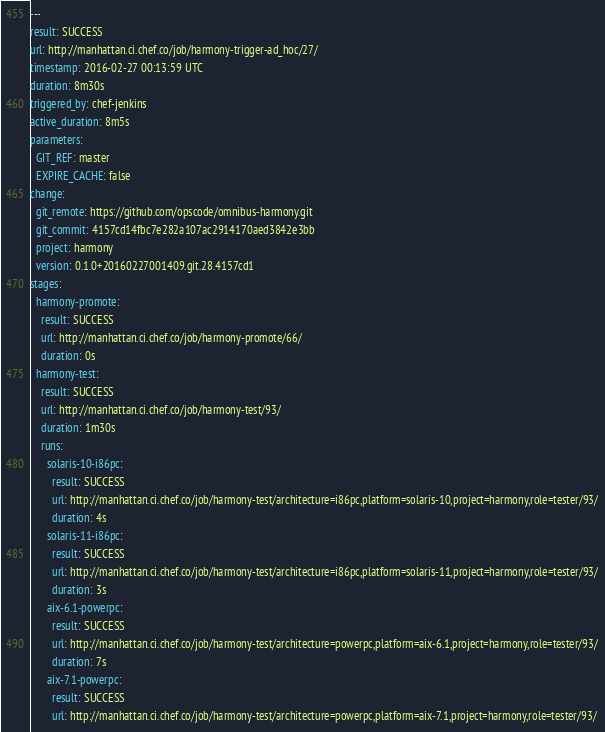Convert code to text. <code><loc_0><loc_0><loc_500><loc_500><_YAML_>---
result: SUCCESS
url: http://manhattan.ci.chef.co/job/harmony-trigger-ad_hoc/27/
timestamp: 2016-02-27 00:13:59 UTC
duration: 8m30s
triggered_by: chef-jenkins
active_duration: 8m5s
parameters:
  GIT_REF: master
  EXPIRE_CACHE: false
change:
  git_remote: https://github.com/opscode/omnibus-harmony.git
  git_commit: 4157cd14fbc7e282a107ac2914170aed3842e3bb
  project: harmony
  version: 0.1.0+20160227001409.git.28.4157cd1
stages:
  harmony-promote:
    result: SUCCESS
    url: http://manhattan.ci.chef.co/job/harmony-promote/66/
    duration: 0s
  harmony-test:
    result: SUCCESS
    url: http://manhattan.ci.chef.co/job/harmony-test/93/
    duration: 1m30s
    runs:
      solaris-10-i86pc:
        result: SUCCESS
        url: http://manhattan.ci.chef.co/job/harmony-test/architecture=i86pc,platform=solaris-10,project=harmony,role=tester/93/
        duration: 4s
      solaris-11-i86pc:
        result: SUCCESS
        url: http://manhattan.ci.chef.co/job/harmony-test/architecture=i86pc,platform=solaris-11,project=harmony,role=tester/93/
        duration: 3s
      aix-6.1-powerpc:
        result: SUCCESS
        url: http://manhattan.ci.chef.co/job/harmony-test/architecture=powerpc,platform=aix-6.1,project=harmony,role=tester/93/
        duration: 7s
      aix-7.1-powerpc:
        result: SUCCESS
        url: http://manhattan.ci.chef.co/job/harmony-test/architecture=powerpc,platform=aix-7.1,project=harmony,role=tester/93/</code> 